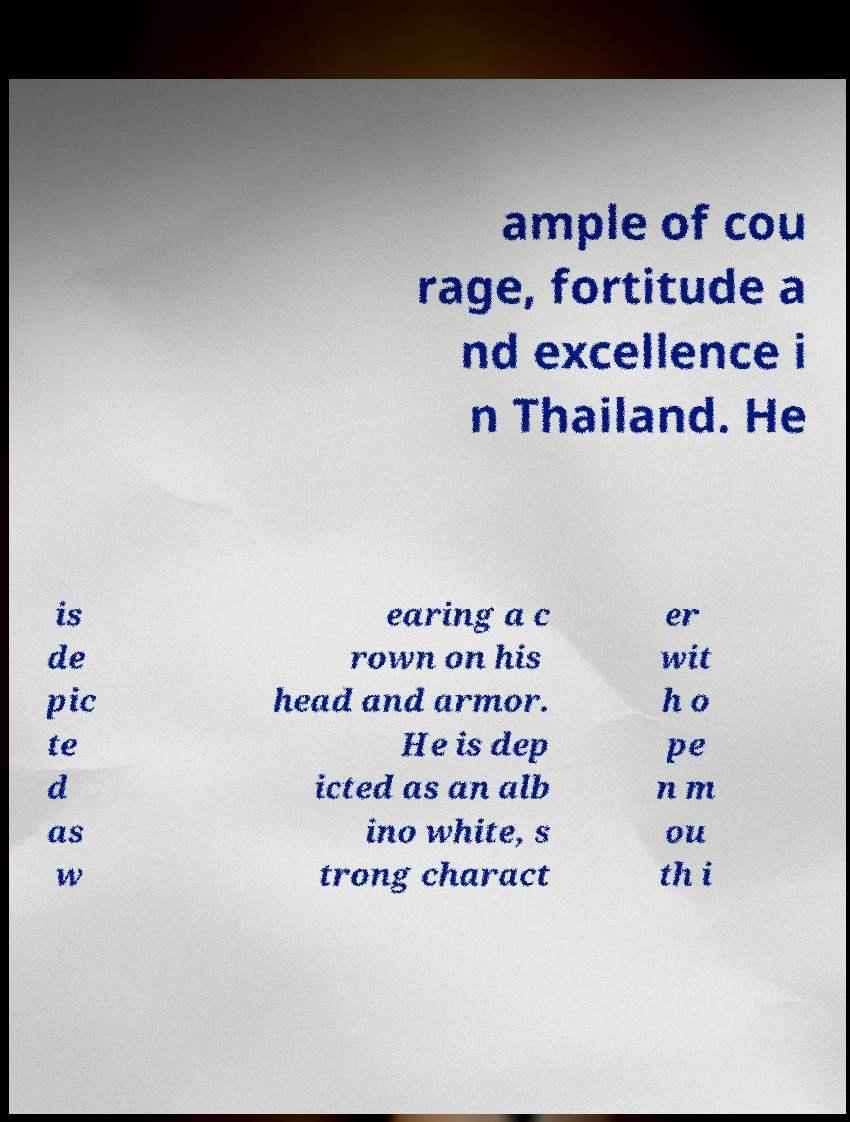Could you extract and type out the text from this image? ample of cou rage, fortitude a nd excellence i n Thailand. He is de pic te d as w earing a c rown on his head and armor. He is dep icted as an alb ino white, s trong charact er wit h o pe n m ou th i 